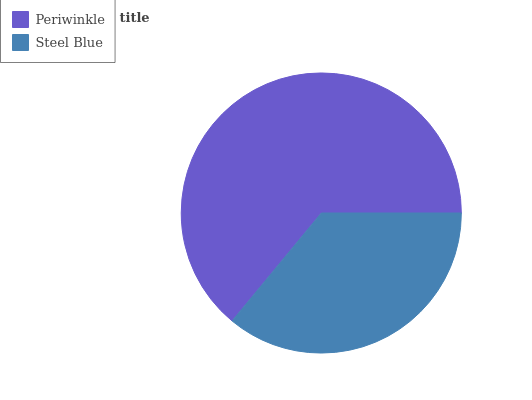Is Steel Blue the minimum?
Answer yes or no. Yes. Is Periwinkle the maximum?
Answer yes or no. Yes. Is Steel Blue the maximum?
Answer yes or no. No. Is Periwinkle greater than Steel Blue?
Answer yes or no. Yes. Is Steel Blue less than Periwinkle?
Answer yes or no. Yes. Is Steel Blue greater than Periwinkle?
Answer yes or no. No. Is Periwinkle less than Steel Blue?
Answer yes or no. No. Is Periwinkle the high median?
Answer yes or no. Yes. Is Steel Blue the low median?
Answer yes or no. Yes. Is Steel Blue the high median?
Answer yes or no. No. Is Periwinkle the low median?
Answer yes or no. No. 